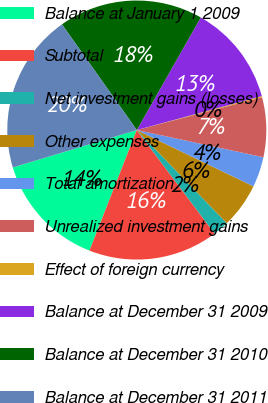Convert chart to OTSL. <chart><loc_0><loc_0><loc_500><loc_500><pie_chart><fcel>Balance at January 1 2009<fcel>Subtotal<fcel>Net investment gains (losses)<fcel>Other expenses<fcel>Total amortization<fcel>Unrealized investment gains<fcel>Effect of foreign currency<fcel>Balance at December 31 2009<fcel>Balance at December 31 2010<fcel>Balance at December 31 2011<nl><fcel>14.38%<fcel>16.21%<fcel>1.97%<fcel>5.62%<fcel>3.79%<fcel>7.45%<fcel>0.14%<fcel>12.55%<fcel>18.03%<fcel>19.86%<nl></chart> 